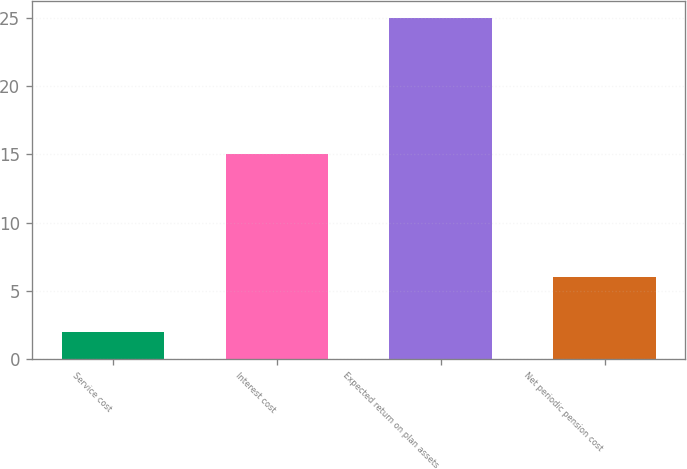Convert chart. <chart><loc_0><loc_0><loc_500><loc_500><bar_chart><fcel>Service cost<fcel>Interest cost<fcel>Expected return on plan assets<fcel>Net periodic pension cost<nl><fcel>2<fcel>15<fcel>25<fcel>6<nl></chart> 